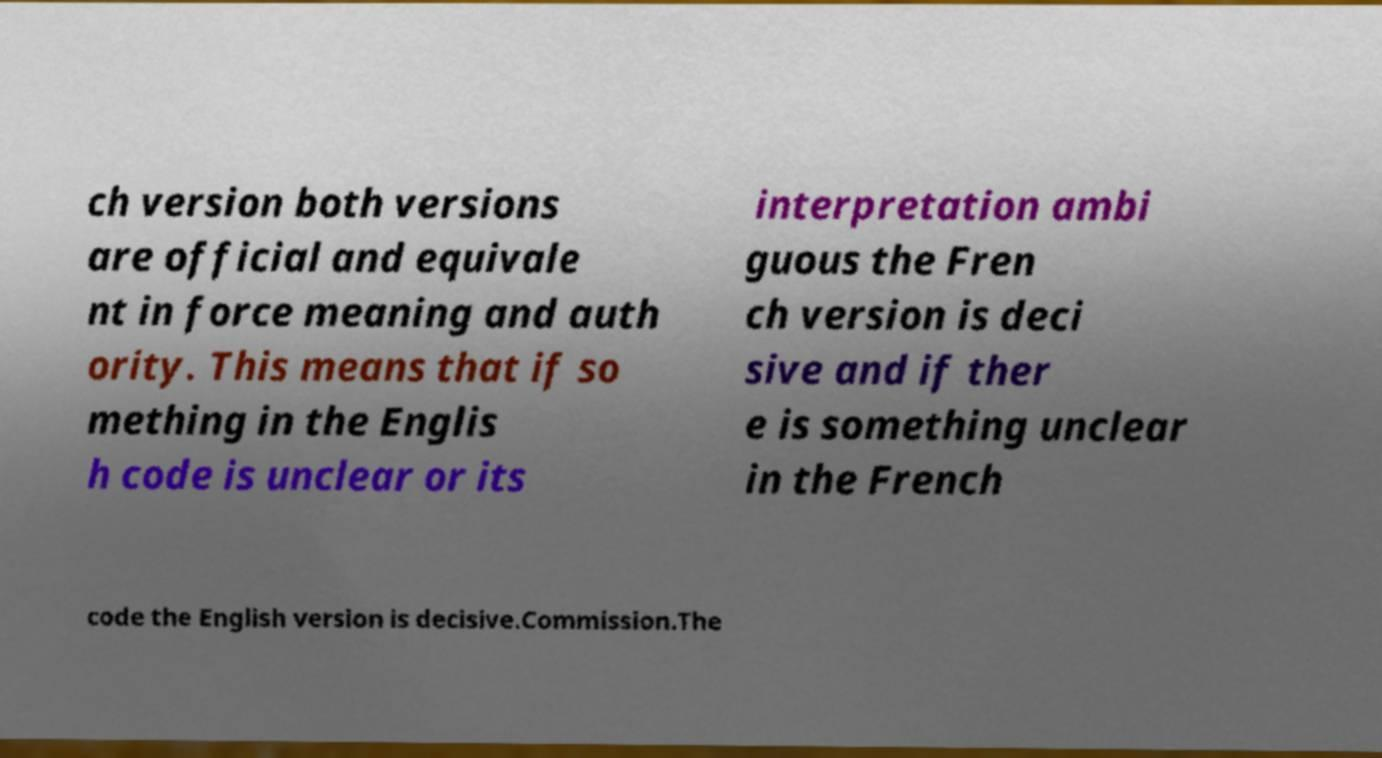Could you extract and type out the text from this image? ch version both versions are official and equivale nt in force meaning and auth ority. This means that if so mething in the Englis h code is unclear or its interpretation ambi guous the Fren ch version is deci sive and if ther e is something unclear in the French code the English version is decisive.Commission.The 